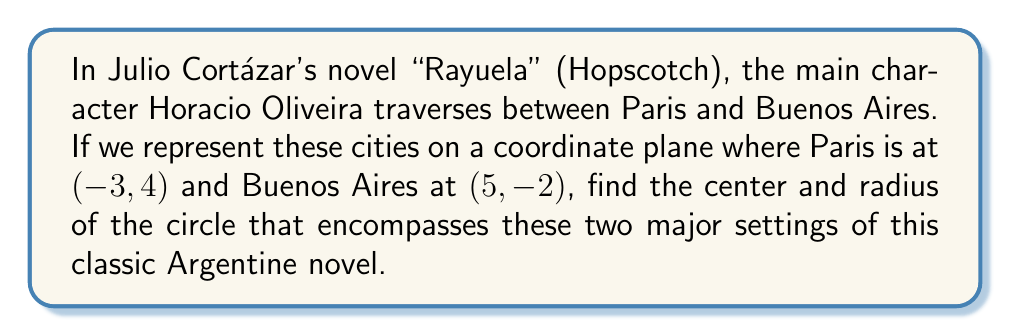Help me with this question. Let's approach this step-by-step:

1) The center of the circle that passes through two points is the midpoint of the line segment connecting these points.

2) To find the midpoint, we average the x-coordinates and y-coordinates separately:

   $x_{center} = \frac{x_1 + x_2}{2} = \frac{-3 + 5}{2} = \frac{2}{2} = 1$
   $y_{center} = \frac{y_1 + y_2}{2} = \frac{4 + (-2)}{2} = \frac{2}{2} = 1$

3) So, the center of the circle is at (1, 1).

4) To find the radius, we can calculate the distance from the center to either point using the distance formula:

   $r = \sqrt{(x_2 - x_1)^2 + (y_2 - y_1)^2}$

   Where $(x_1, y_1)$ is the center and $(x_2, y_2)$ is either Paris or Buenos Aires.

5) Let's use Paris (-3, 4):

   $r = \sqrt{(-3 - 1)^2 + (4 - 1)^2}$
   $r = \sqrt{(-4)^2 + 3^2}$
   $r = \sqrt{16 + 9}$
   $r = \sqrt{25}$
   $r = 5$

6) We can verify this with Buenos Aires (5, -2):

   $r = \sqrt{(5 - 1)^2 + (-2 - 1)^2}$
   $r = \sqrt{4^2 + (-3)^2}$
   $r = \sqrt{16 + 9}$
   $r = \sqrt{25}$
   $r = 5$

Therefore, the circle has its center at (1, 1) and a radius of 5 units.
Answer: Center: (1, 1), Radius: 5 